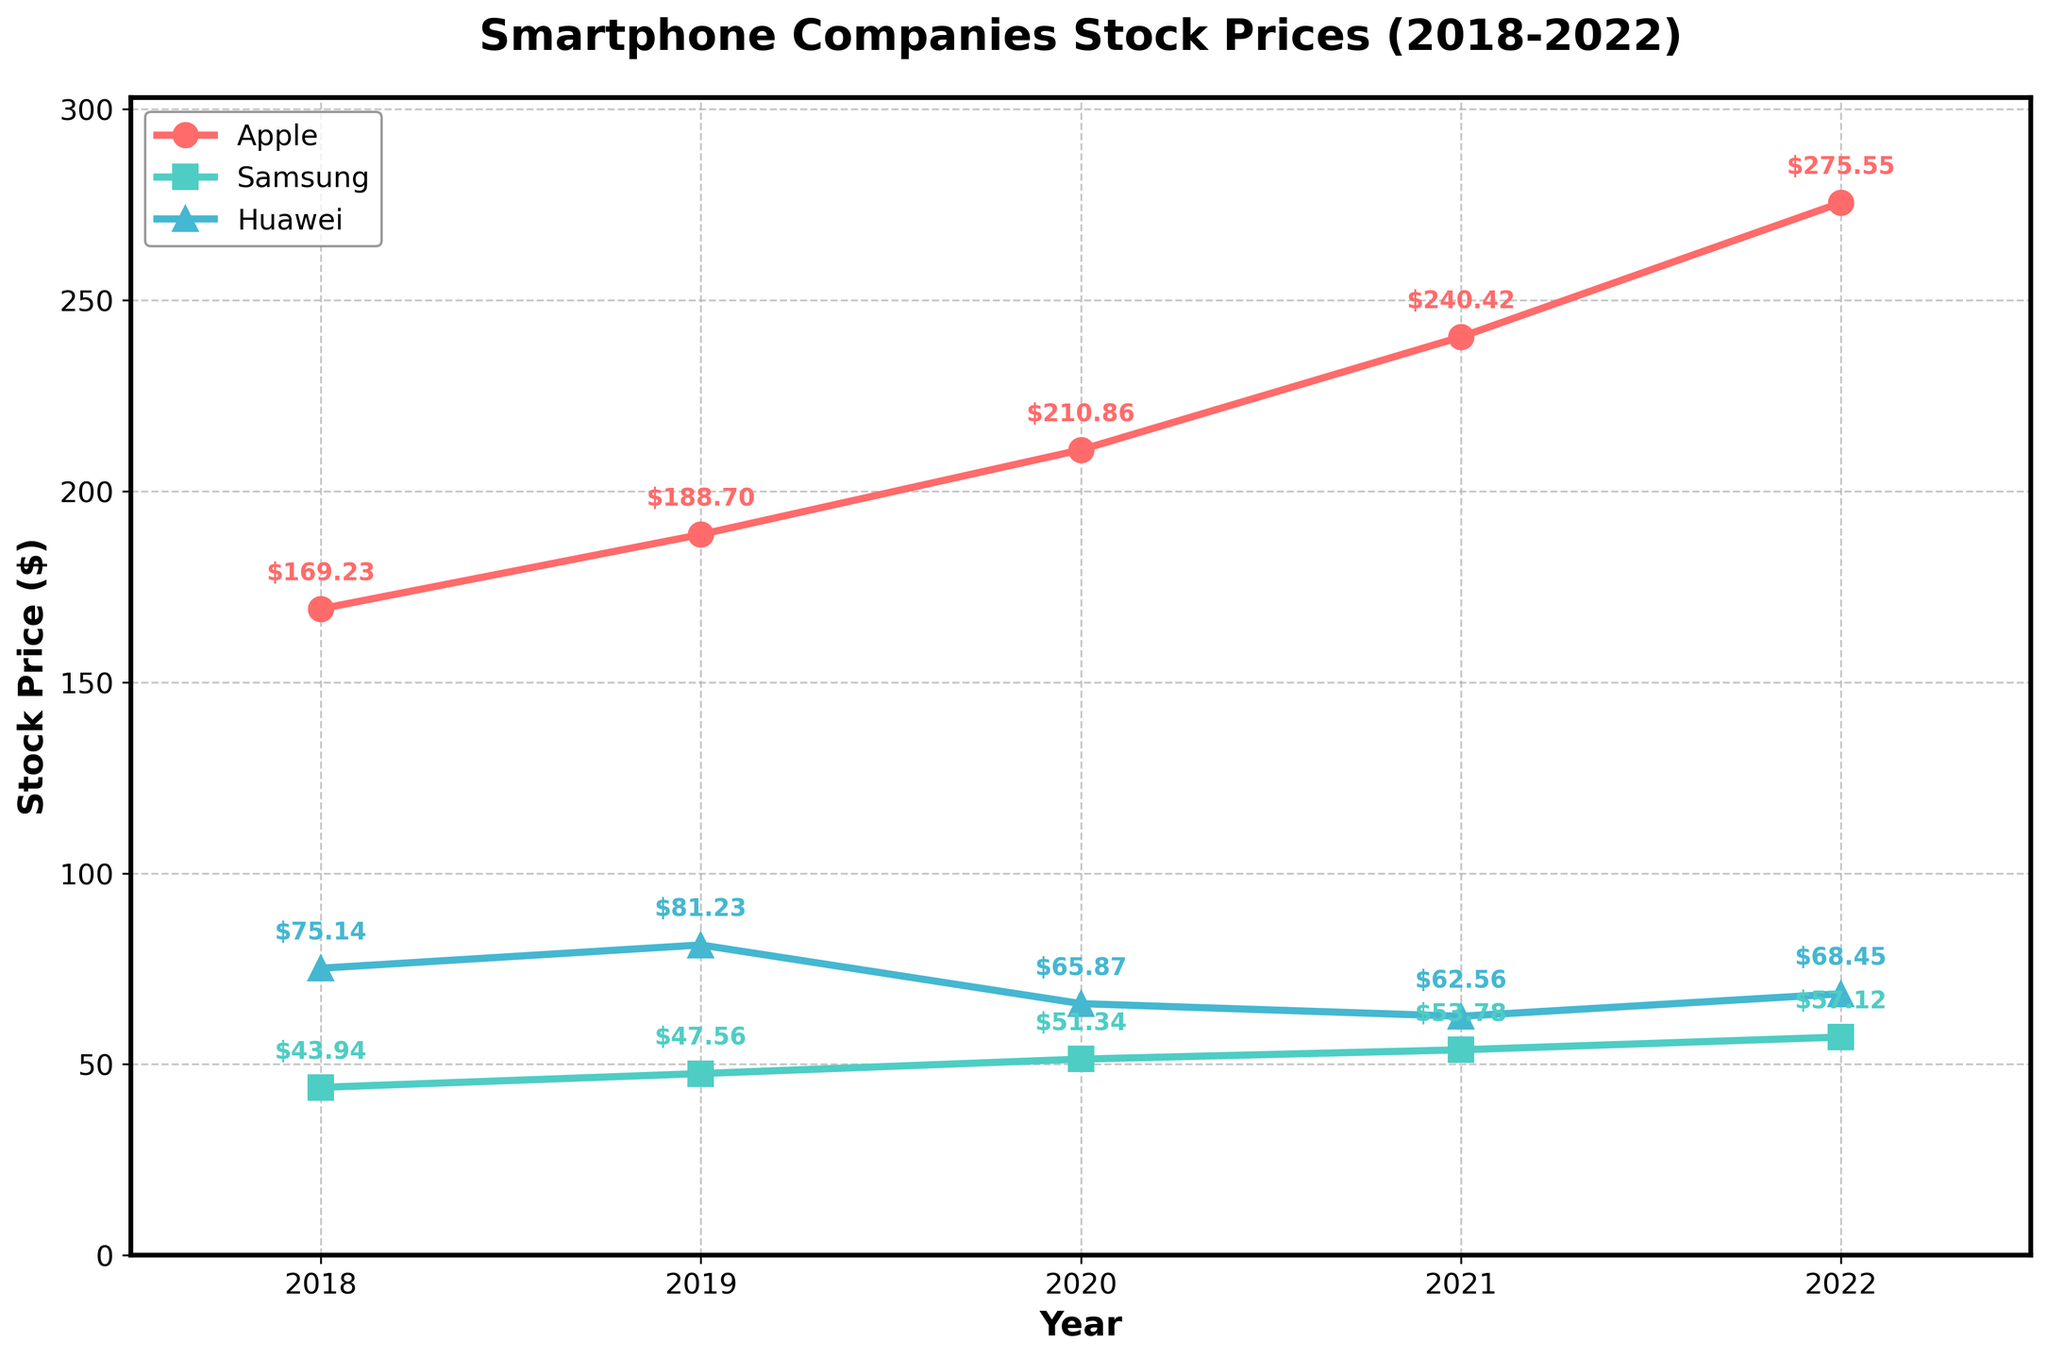What is the title of the plot? The title of the plot is displayed at the top of the figure in bold text.
Answer: Smartphone Companies Stock Prices (2018-2022) What companies are compared in the plot? The plot compares multiple companies. Refer to the legend in the upper left corner to identify the companies.
Answer: Apple, Samsung, Huawei Which company had the highest stock price in 2022? To find the company with the highest stock price in 2022, look at the stock prices on the right end of the plot and identify the highest value.
Answer: Apple Compare Apple and Samsung's stock prices in 2020. Which company had a higher stock price? Compare the stock prices at the 2020 mark for both Apple and Samsung by tracing the lines and reading the annotated values.
Answer: Apple How much did Apple's stock price increase from 2018 to 2022? Subtract Apple's stock price in 2018 from its stock price in 2022. Apple's 2022 stock price is $275.55, and its 2018 stock price is $169.23. So, $275.55 - $169.23 = $106.32
Answer: $106.32 Which company had the most consistent stock price trend from 2018 to 2022? To determine consistency, observe how straight and smooth the company's line is over the years without sharp increases or decreases.
Answer: Samsung What was Samsung's stock price trend from 2018 to 2022? Trace the line representing Samsung's stock price from 2018 to 2022 and describe the general direction and changes. Samsung's stock price shows a steady upward trend.
Answer: Steady increase In what year did Huawei experience the largest drop in stock price? Identify the year-to-year changes for Huawei, looking for the year with the most significant decrease in the annotated stock prices.
Answer: 2020 By how much did Huawei's stock price decrease from 2019 to 2020? Subtract Huawei's stock price in 2020 from its stock price in 2019. Huawei's 2019 stock price is $81.23, and its 2020 stock price is $65.87. So, $81.23 - $65.87 = $15.36
Answer: $15.36 Which company had the lowest stock price in 2018? Look at the stock prices on the left end of the plot for 2018 and identify the lowest value among the companies.
Answer: Samsung 